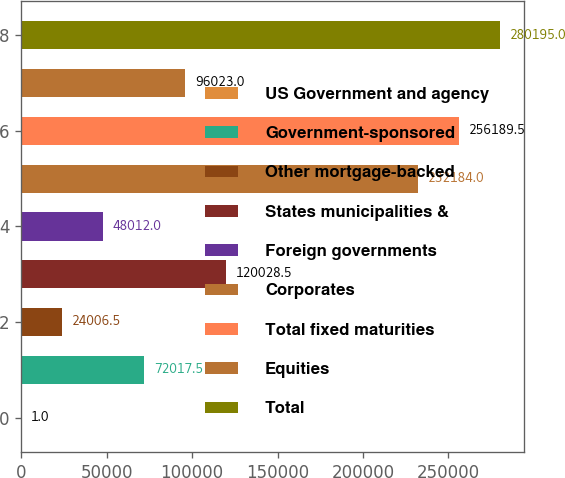Convert chart. <chart><loc_0><loc_0><loc_500><loc_500><bar_chart><fcel>US Government and agency<fcel>Government-sponsored<fcel>Other mortgage-backed<fcel>States municipalities &<fcel>Foreign governments<fcel>Corporates<fcel>Total fixed maturities<fcel>Equities<fcel>Total<nl><fcel>1<fcel>72017.5<fcel>24006.5<fcel>120028<fcel>48012<fcel>232184<fcel>256190<fcel>96023<fcel>280195<nl></chart> 